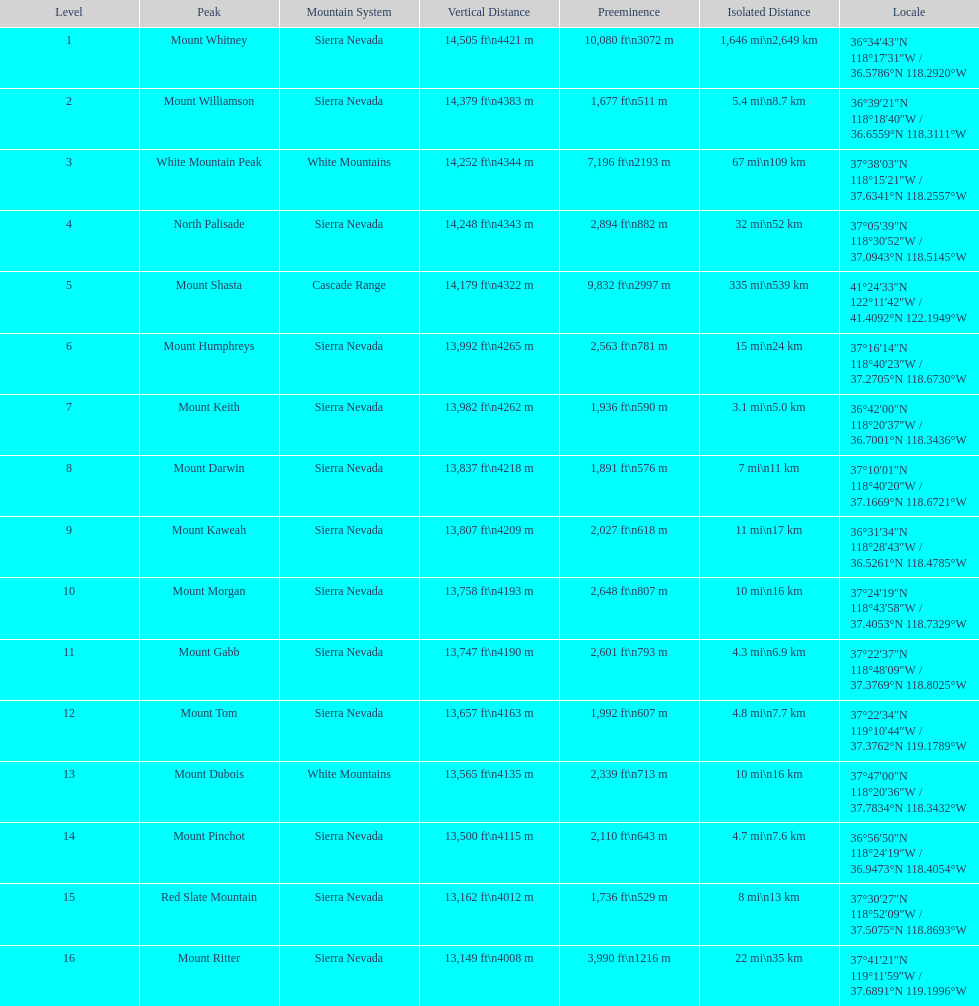On which mountain top can one find the greatest isolation? Mount Whitney. 